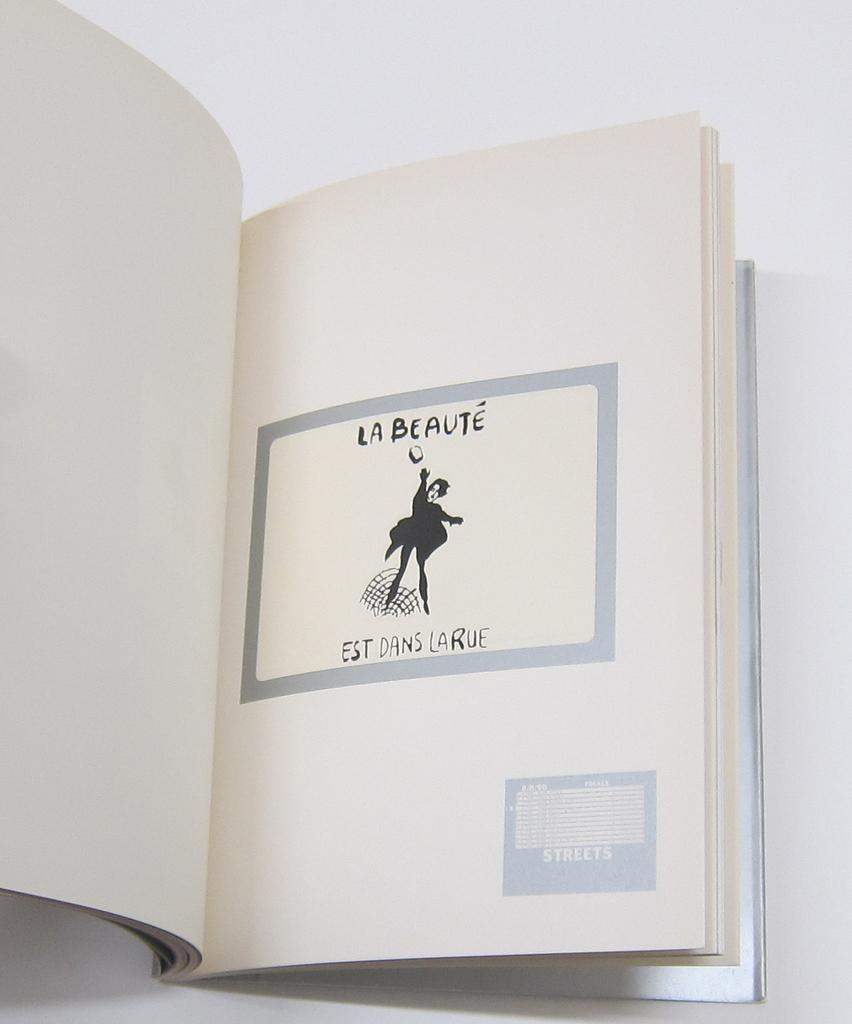<image>
Offer a succinct explanation of the picture presented. A book is open to a page with an image in the center of the page and the words La Beaute. 